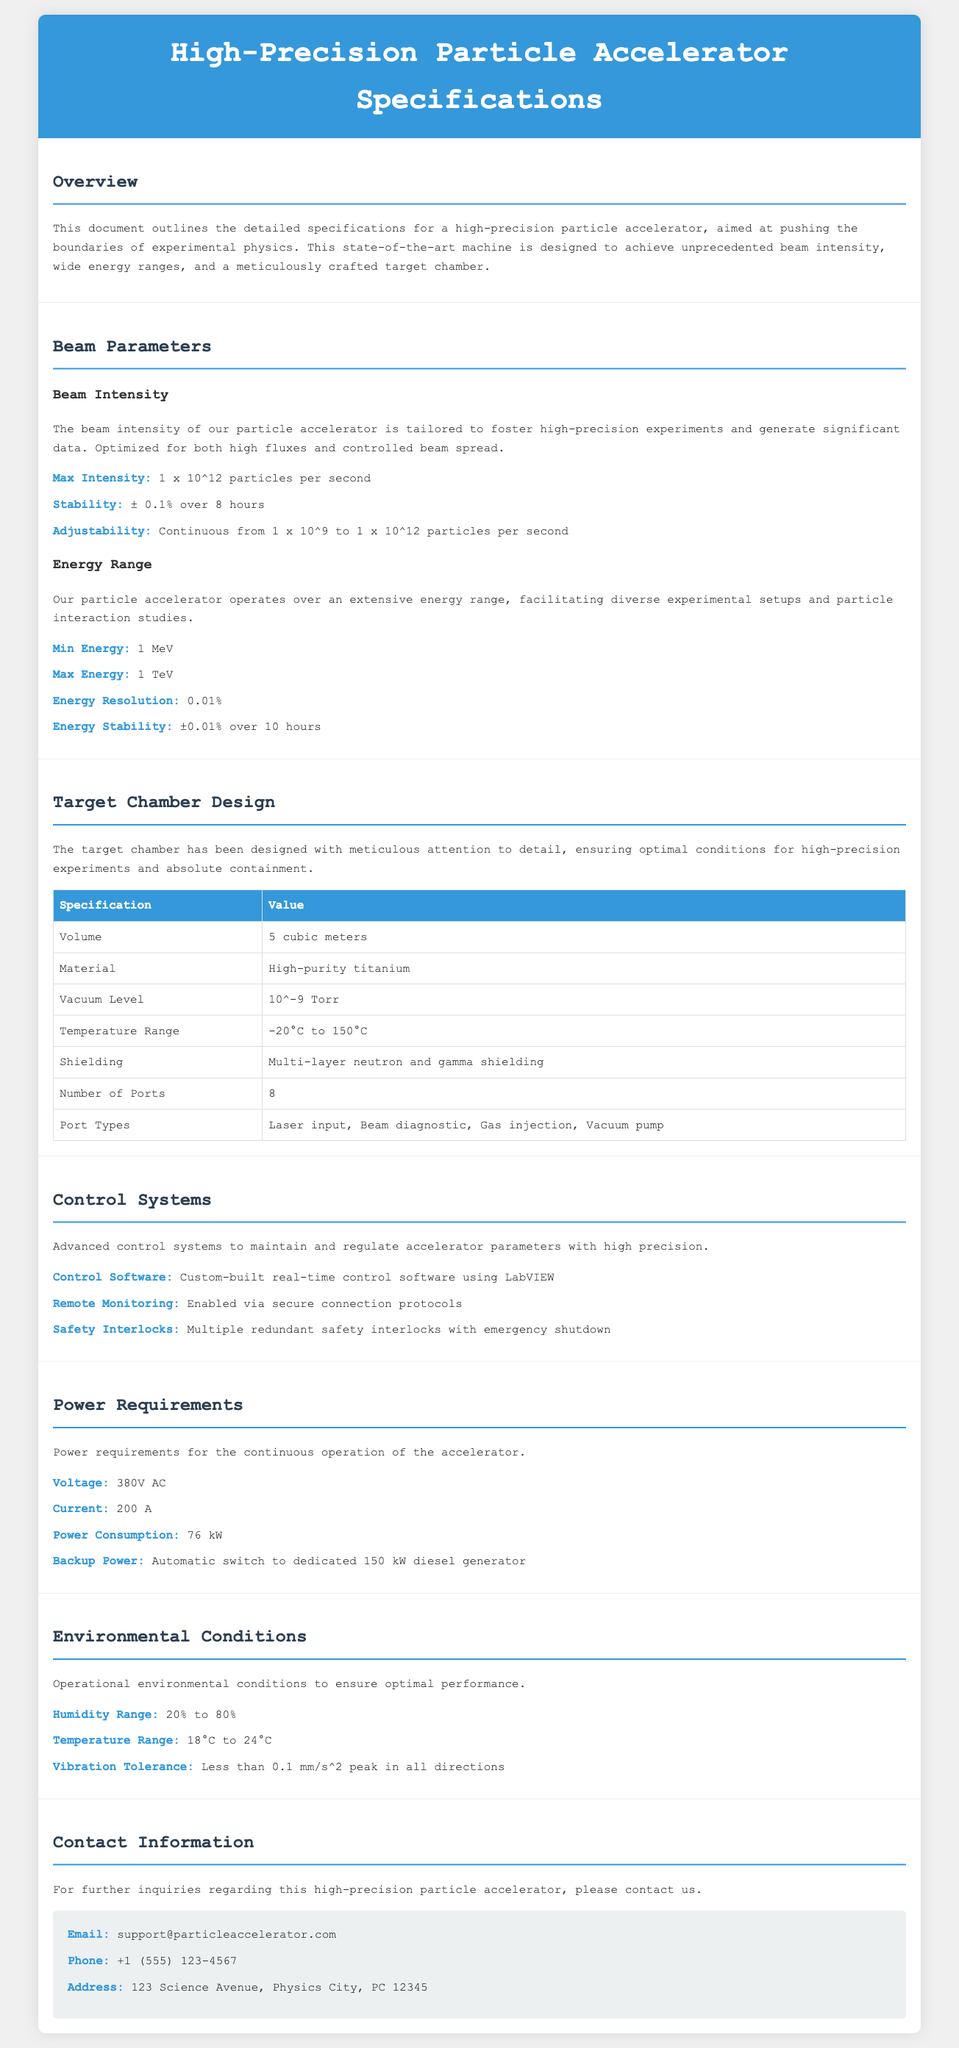what is the maximum intensity of the beam? The maximum intensity is specified in the document under the Beam Parameters section.
Answer: 1 x 10^12 particles per second what material is the target chamber made of? The material for the target chamber is detailed in the Target Chamber Design section.
Answer: High-purity titanium what is the minimum energy of the accelerator? The minimum energy is listed in the Energy Range section of the document.
Answer: 1 MeV how many ports does the target chamber have? The number of ports is shown in the table under Target Chamber Design.
Answer: 8 what is the vacuum level specified for the target chamber? The vacuum level is outlined in the Target Chamber Design section of the document.
Answer: 10^-9 Torr what is the energy stability over a period of time? Energy stability is mentioned in the Energy Range section. It specifies a certain stability over time.
Answer: ±0.01% over 10 hours what is the power consumption for the accelerator? Power consumption is stated in the Power Requirements section.
Answer: 76 kW what system is used for remote monitoring? Remote monitoring details are provided in the Control Systems section.
Answer: Secure connection protocols what is the temperature range that the accelerator operates in? The operational temperature range is indicated in the Environmental Conditions section.
Answer: 18°C to 24°C 